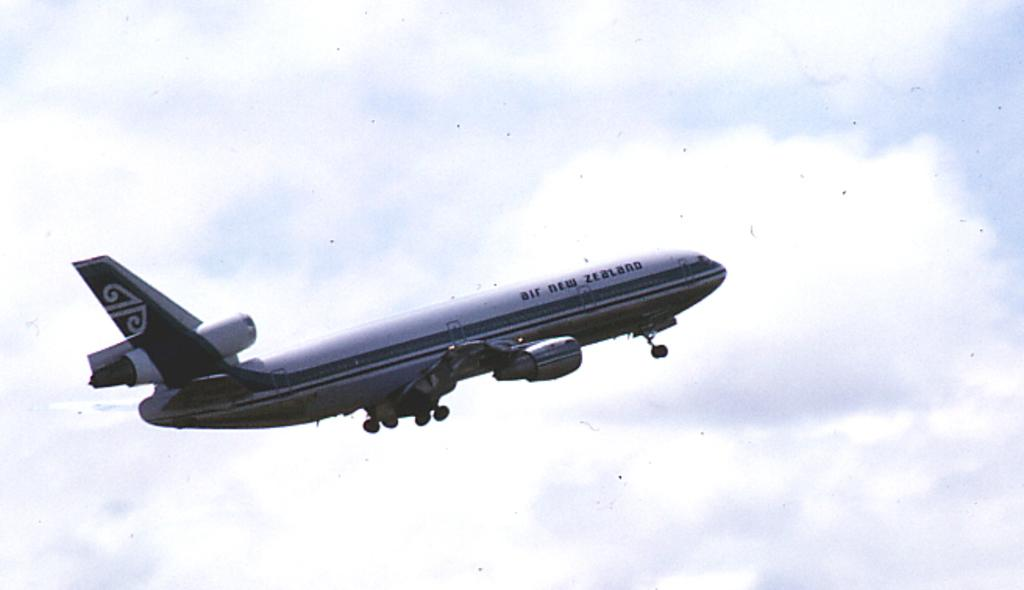What is the main subject of the image? The main subject of the image is an airplane. What is the airplane doing in the image? The airplane is flying in the air. What can be seen in the background of the image? The sky is visible in the background of the image. What type of plantation can be seen in the image? There is no plantation present in the image; it features an airplane flying in the sky. What kind of wine is being served on the island in the image? There is no island or wine present in the image; it only shows an airplane flying in the sky. 